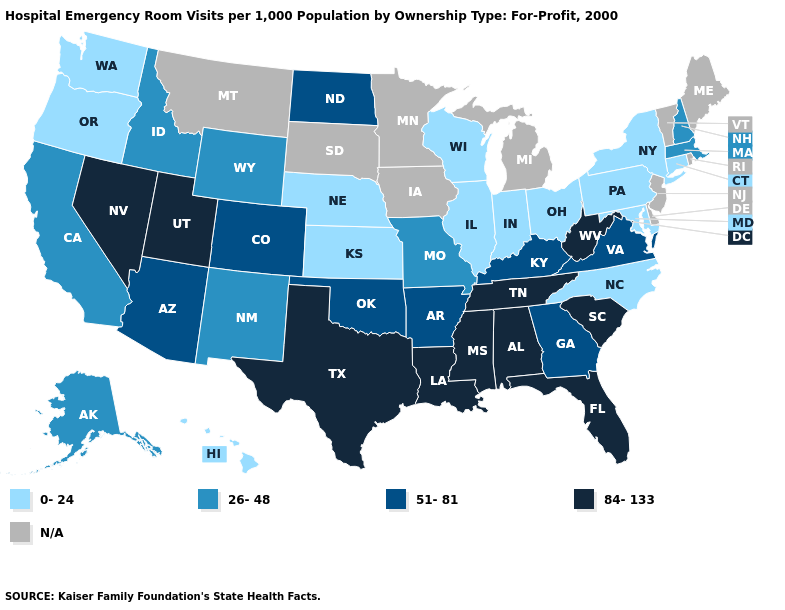Name the states that have a value in the range 51-81?
Keep it brief. Arizona, Arkansas, Colorado, Georgia, Kentucky, North Dakota, Oklahoma, Virginia. Does Idaho have the lowest value in the West?
Keep it brief. No. How many symbols are there in the legend?
Short answer required. 5. What is the value of West Virginia?
Keep it brief. 84-133. What is the highest value in the USA?
Write a very short answer. 84-133. How many symbols are there in the legend?
Short answer required. 5. Which states have the highest value in the USA?
Answer briefly. Alabama, Florida, Louisiana, Mississippi, Nevada, South Carolina, Tennessee, Texas, Utah, West Virginia. Name the states that have a value in the range 26-48?
Answer briefly. Alaska, California, Idaho, Massachusetts, Missouri, New Hampshire, New Mexico, Wyoming. Does Kentucky have the lowest value in the USA?
Keep it brief. No. What is the value of North Carolina?
Short answer required. 0-24. 